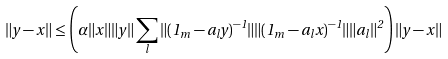Convert formula to latex. <formula><loc_0><loc_0><loc_500><loc_500>\| y - x \| \leq \left ( \alpha \| x \| \| y \| \sum _ { l } \| ( 1 _ { m } - a _ { l } y ) ^ { - 1 } \| \| ( 1 _ { m } - a _ { l } x ) ^ { - 1 } \| \| a _ { l } \| ^ { 2 } \right ) \| y - x \|</formula> 